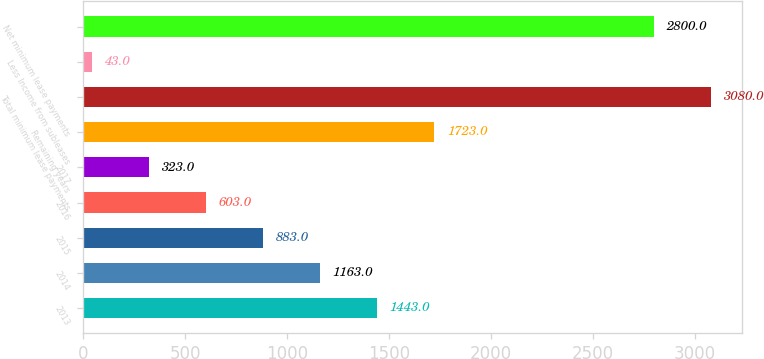<chart> <loc_0><loc_0><loc_500><loc_500><bar_chart><fcel>2013<fcel>2014<fcel>2015<fcel>2016<fcel>2017<fcel>Remaining years<fcel>Total minimum lease payments<fcel>Less Income from subleases<fcel>Net minimum lease payments<nl><fcel>1443<fcel>1163<fcel>883<fcel>603<fcel>323<fcel>1723<fcel>3080<fcel>43<fcel>2800<nl></chart> 